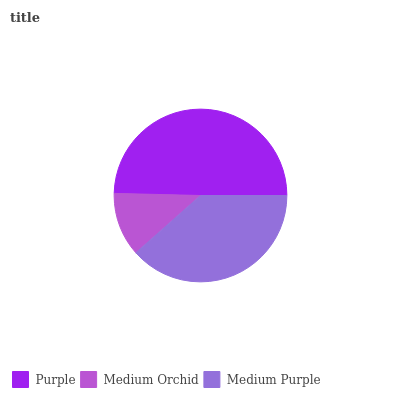Is Medium Orchid the minimum?
Answer yes or no. Yes. Is Purple the maximum?
Answer yes or no. Yes. Is Medium Purple the minimum?
Answer yes or no. No. Is Medium Purple the maximum?
Answer yes or no. No. Is Medium Purple greater than Medium Orchid?
Answer yes or no. Yes. Is Medium Orchid less than Medium Purple?
Answer yes or no. Yes. Is Medium Orchid greater than Medium Purple?
Answer yes or no. No. Is Medium Purple less than Medium Orchid?
Answer yes or no. No. Is Medium Purple the high median?
Answer yes or no. Yes. Is Medium Purple the low median?
Answer yes or no. Yes. Is Purple the high median?
Answer yes or no. No. Is Medium Orchid the low median?
Answer yes or no. No. 